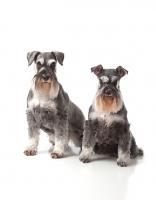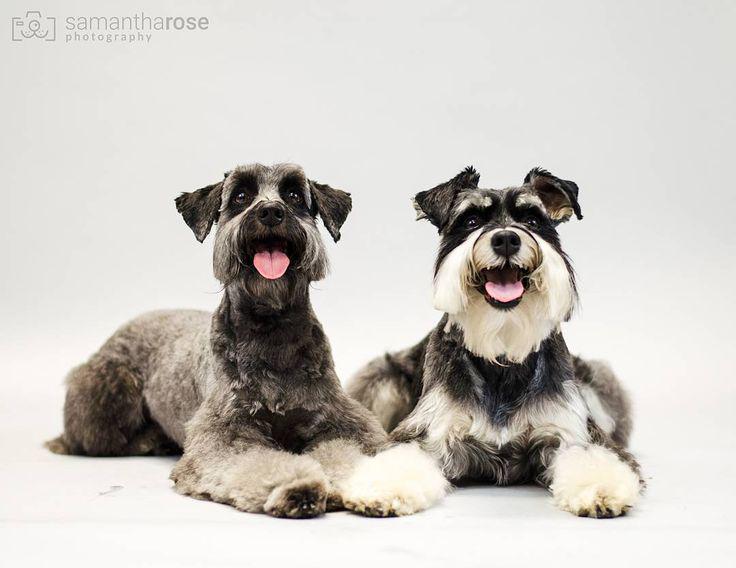The first image is the image on the left, the second image is the image on the right. Given the left and right images, does the statement "in the right pic the dog is wearing something" hold true? Answer yes or no. No. The first image is the image on the left, the second image is the image on the right. Considering the images on both sides, is "There are at least 3 dogs and 2 are sitting in these." valid? Answer yes or no. Yes. 